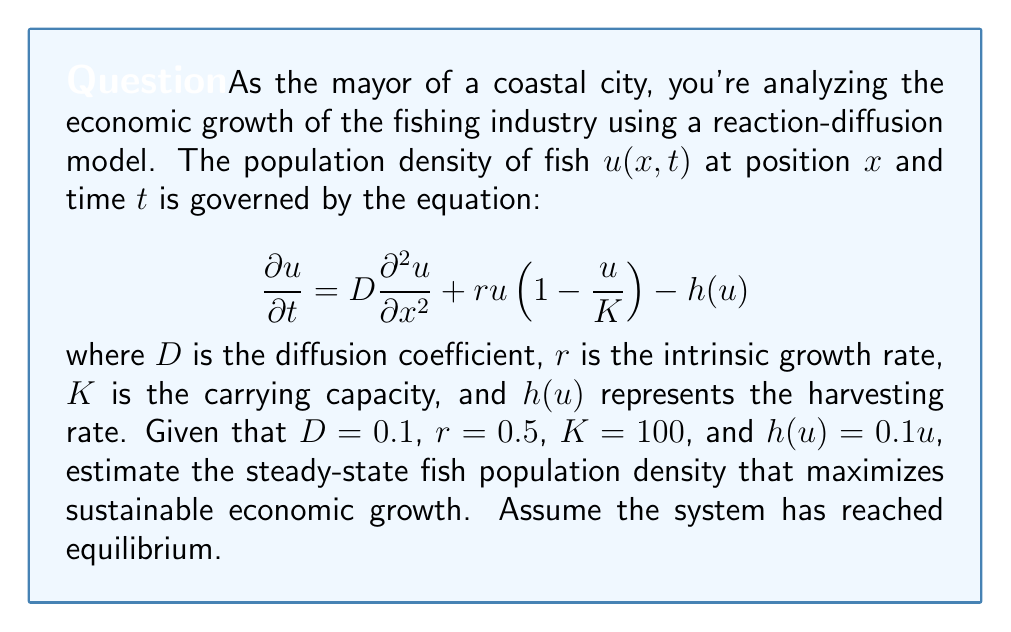Can you solve this math problem? To solve this problem, we need to follow these steps:

1) At steady state, the time derivative is zero, so we have:

   $$0 = D\frac{\partial^2 u}{\partial x^2} + ru(1-\frac{u}{K}) - h(u)$$

2) Assuming spatial homogeneity at equilibrium, the spatial derivative is also zero:

   $$0 = ru(1-\frac{u}{K}) - h(u)$$

3) Substituting the given values:

   $$0 = 0.5u(1-\frac{u}{100}) - 0.1u$$

4) Expanding the equation:

   $$0 = 0.5u - 0.005u^2 - 0.1u$$

5) Simplifying:

   $$0 = 0.4u - 0.005u^2$$

6) Factoring out $u$:

   $$0 = u(0.4 - 0.005u)$$

7) Solving for $u$:

   Either $u = 0$ or $0.4 - 0.005u = 0$

   From the second equation: $u = 80$

8) The solution $u = 0$ represents extinction, which is not economically viable. Therefore, the steady-state population density that maximizes sustainable economic growth is 80.

This solution represents the maximum sustainable yield, balancing growth and harvesting to maintain a stable population while allowing for maximum economic benefit.
Answer: The steady-state fish population density that maximizes sustainable economic growth is 80 fish per unit area. 